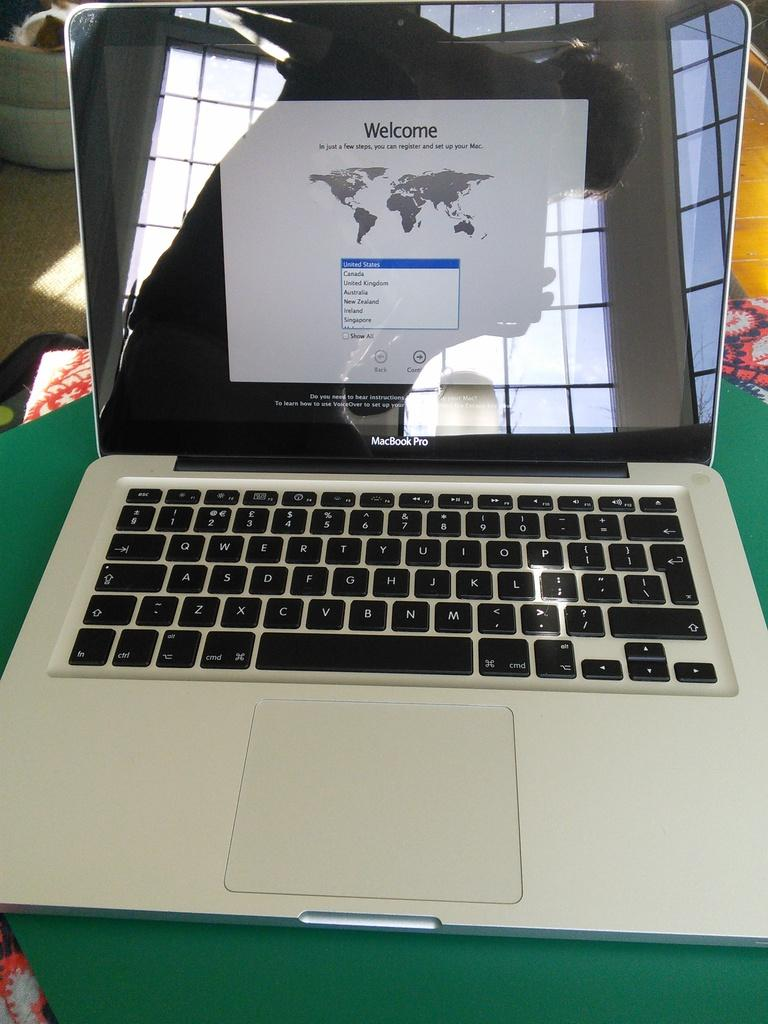<image>
Write a terse but informative summary of the picture. macbook pro with the registration welcome page on the screen 